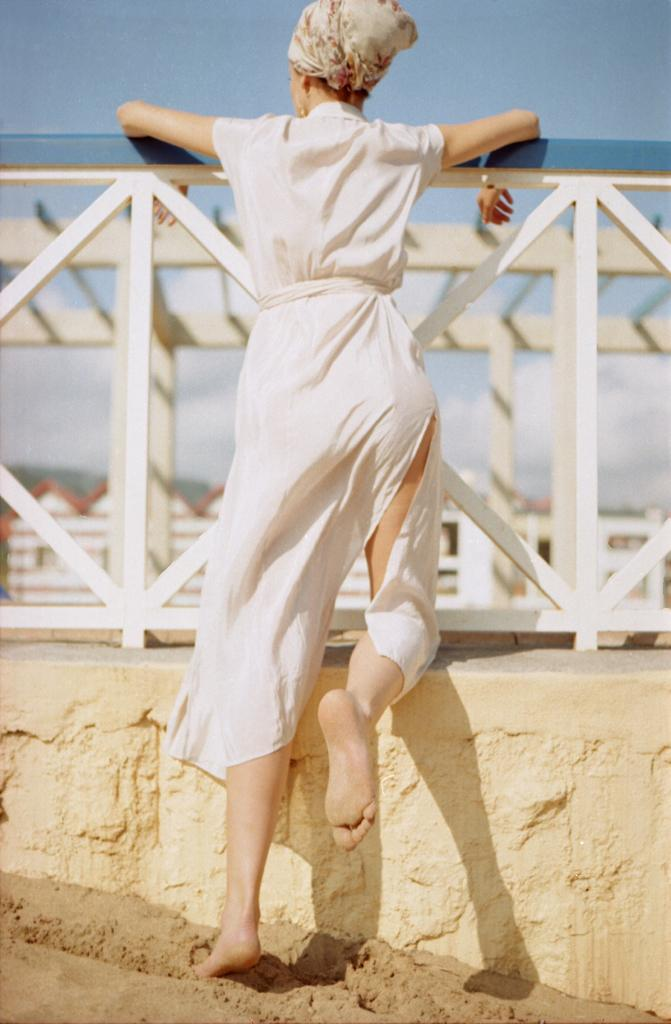What is the woman in the image doing? The woman is standing beside a fence in the image. What can be seen behind the woman? There is a wall visible in the image. What type of terrain is present in the image? There is sand in the image. What structures can be seen in the background? There are houses and a roof with stone pillars visible in the background. What is visible above the structures in the image? The sky is visible in the image. How many tickets does the woman have in her hand in the image? There is no indication in the image that the woman has any tickets in her hand. What type of respect is being shown by the stone in the image? There is no stone present in the image, and therefore no such interaction can be observed. 